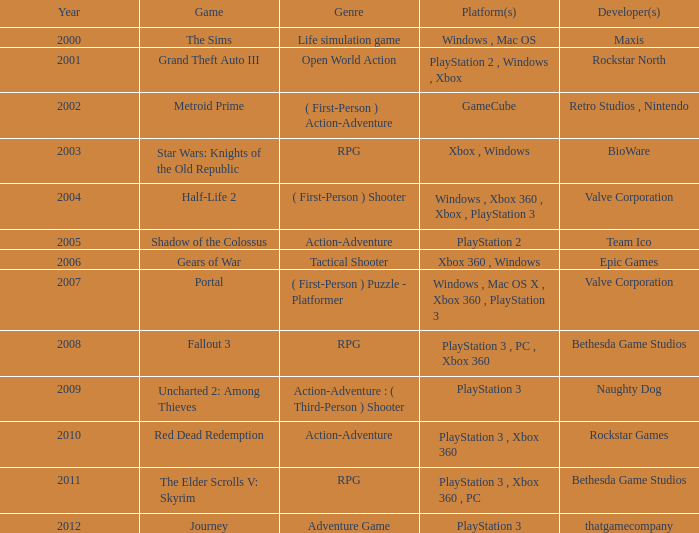Which platform has rockstar games as its developer? PlayStation 3 , Xbox 360. 